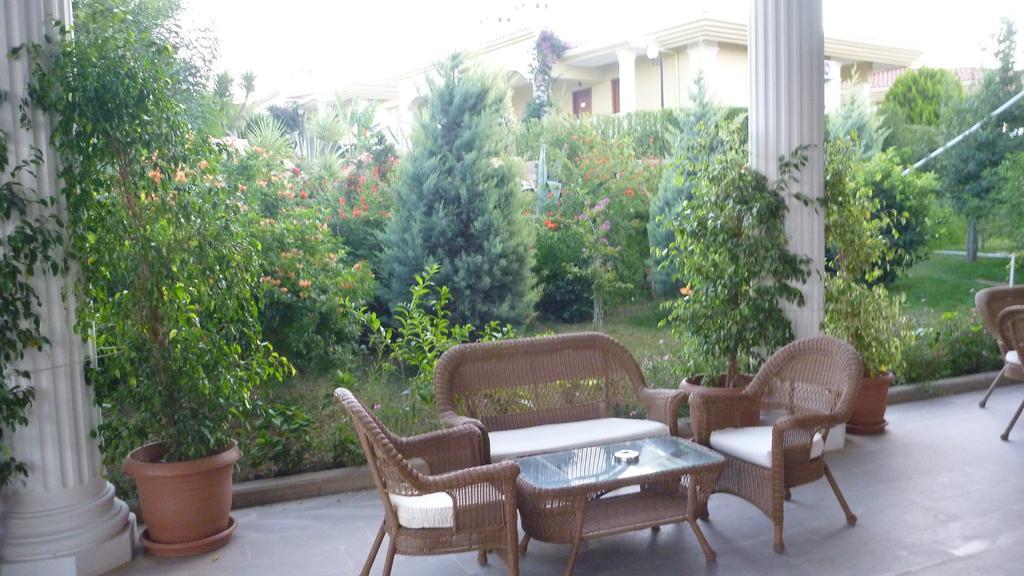How would you summarize this image in a sentence or two? Picture is taken in the garden in which there is a sofa and chairs beside the garden. There is a table in between them at the background there is a building,trees and flower pot. 